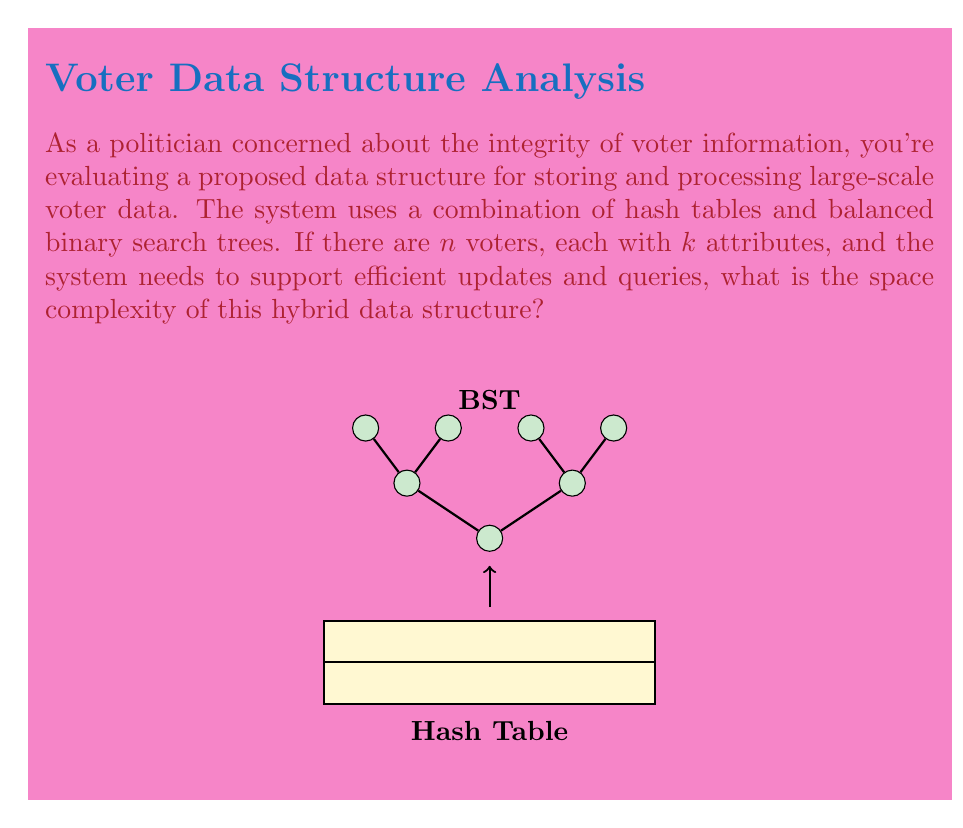Solve this math problem. Let's break down the space complexity analysis step-by-step:

1) Hash Table Component:
   - Each voter's information is stored in the hash table.
   - There are $n$ voters, each with $k$ attributes.
   - Space required for hash table: $O(n \cdot k)$

2) Balanced Binary Search Tree (BST) Component:
   - The BST is used for efficient querying and updating.
   - It stores references to the voter data in the hash table.
   - There are $n$ nodes in the BST, one for each voter.
   - Each node typically contains a key, value (reference), and pointers to left and right children.
   - Space required for BST: $O(n)$

3) Total Space Complexity:
   - Combine the space requirements of both components.
   - Total space = Hash Table space + BST space
   - $O(n \cdot k) + O(n) = O(n \cdot k + n)$
   
4) Simplification:
   - Since $k$ is typically much smaller than $n$ and is often considered constant,
     we can simplify the expression.
   - If $k$ is considered constant: $O(n \cdot k + n) = O(n)$
   - If $k$ is variable: $O(n \cdot k + n) = O(n \cdot k)$

5) Final Consideration:
   - As a politician concerned with data integrity, it's crucial to note that 
     this space complexity ensures that each voter's information is stored once
     and can be efficiently accessed and updated, which is essential for 
     maintaining accurate voter records.
Answer: $O(n \cdot k)$ 